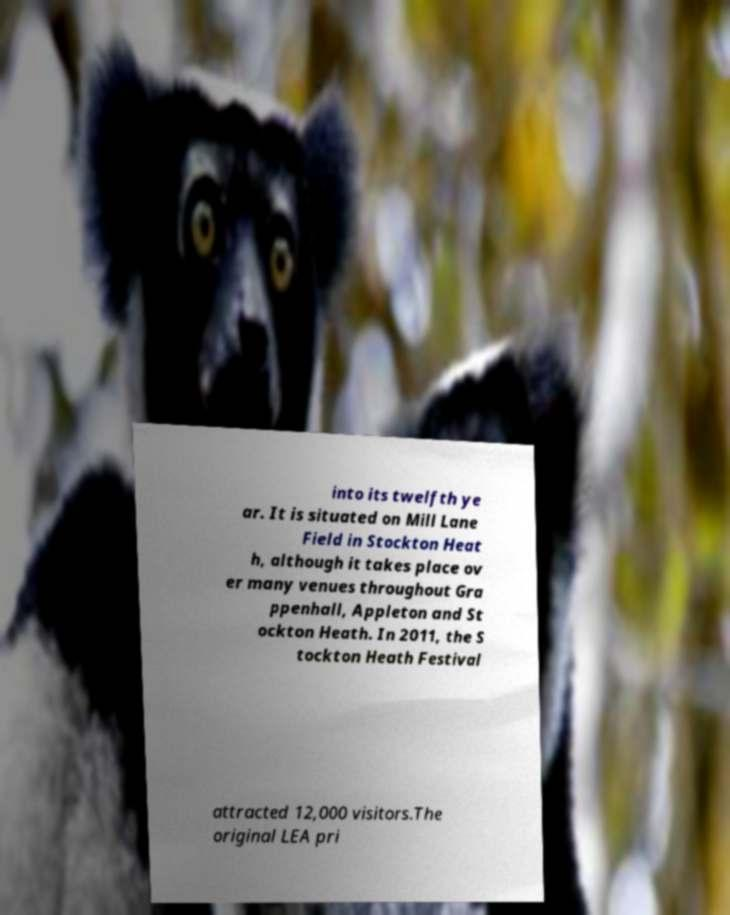What messages or text are displayed in this image? I need them in a readable, typed format. into its twelfth ye ar. It is situated on Mill Lane Field in Stockton Heat h, although it takes place ov er many venues throughout Gra ppenhall, Appleton and St ockton Heath. In 2011, the S tockton Heath Festival attracted 12,000 visitors.The original LEA pri 